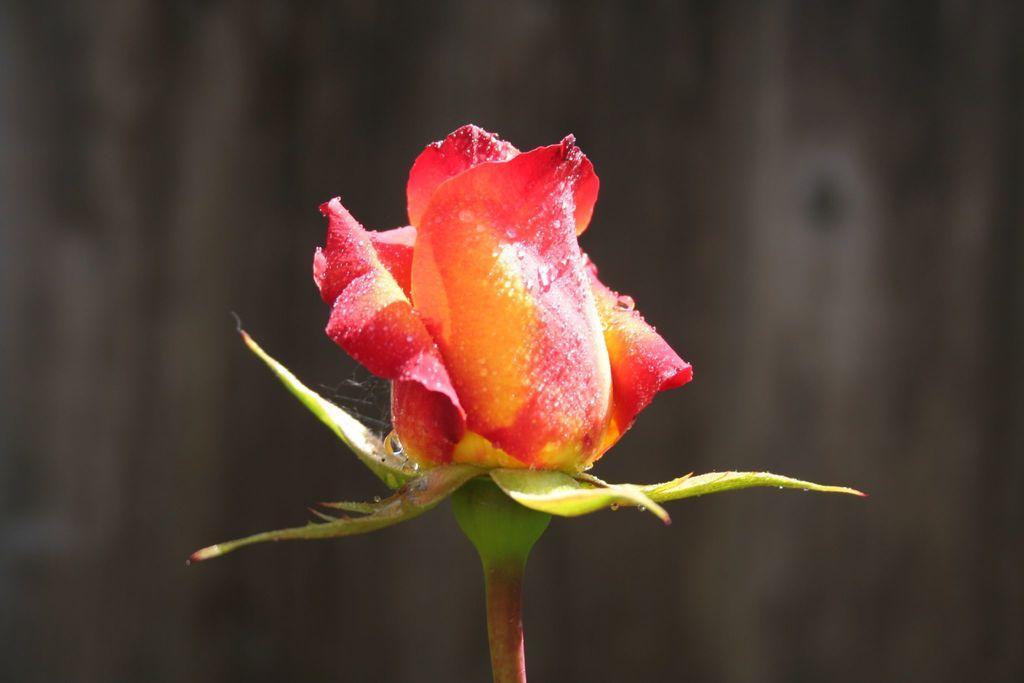In one or two sentences, can you explain what this image depicts? In this image we can see a rose bud. 